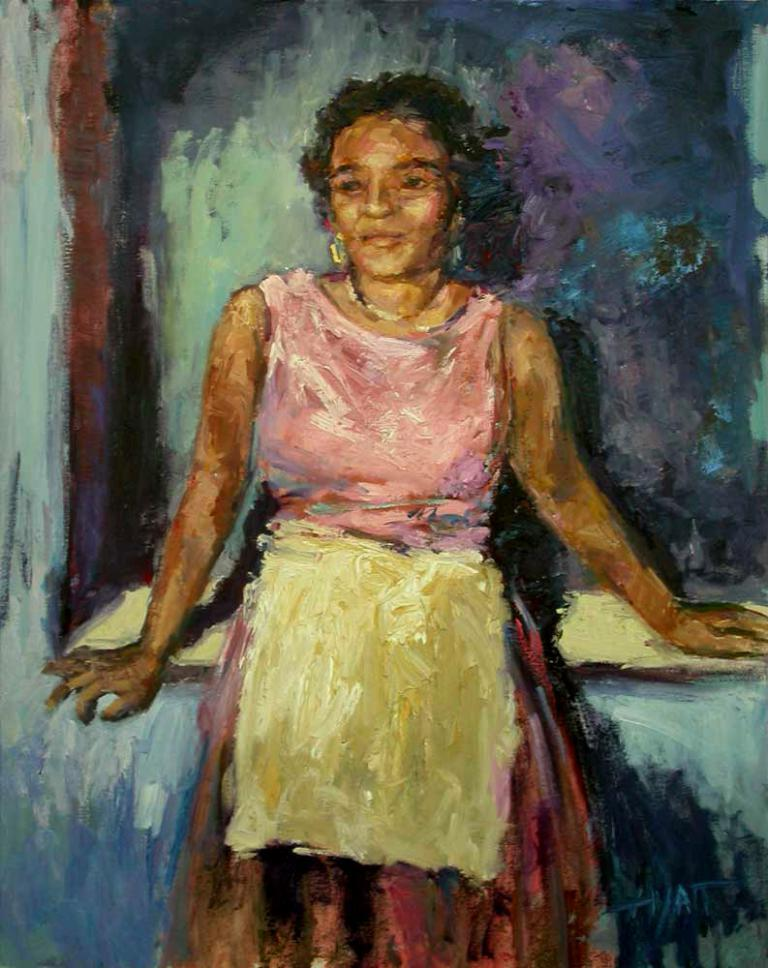What is the main subject of the image? There is a painting in the image. What is the painting depicting? The painting depicts a woman standing. What type of desk can be seen in the painting? There is no desk present in the painting; it depicts a woman standing. What design elements are present in the painting? The provided facts do not mention any specific design elements in the painting, so we cannot answer this question definitively. 